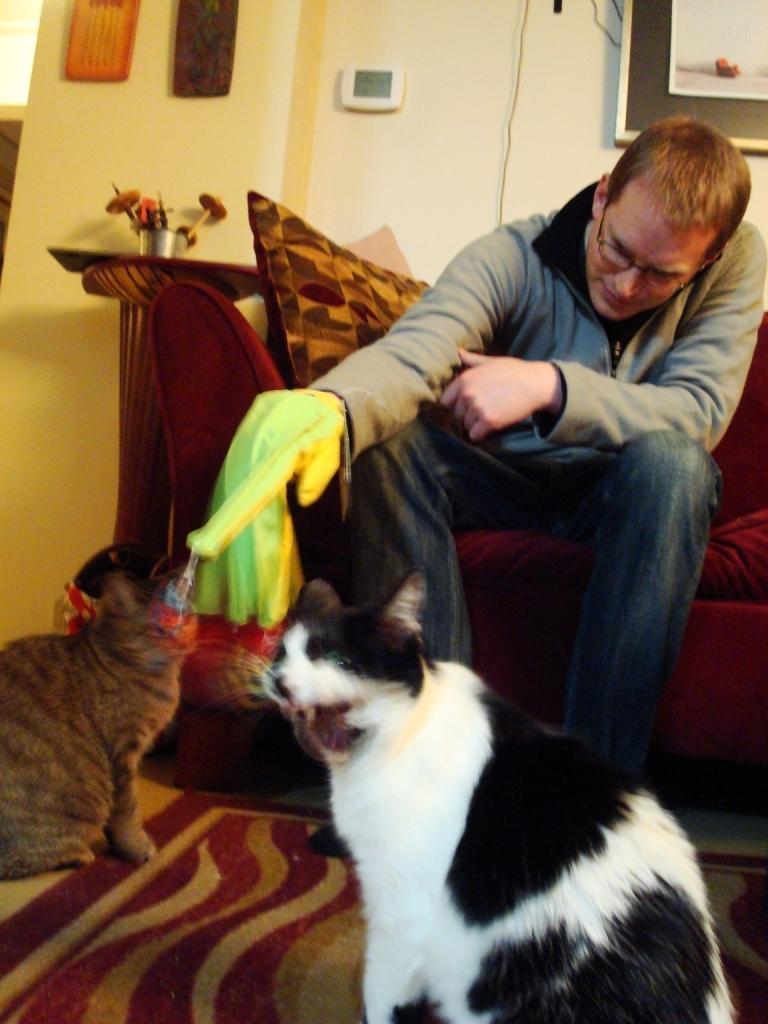Describe this image in one or two sentences. In this image, we can see a person wearing spectacles is sitting on the sofa. We can also see some cats and the ground with the mat. We can see the wall with a poster and some objects. We can also see a table with some objects on it. 